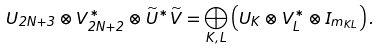Convert formula to latex. <formula><loc_0><loc_0><loc_500><loc_500>U _ { 2 N + 3 } \otimes V ^ { * } _ { 2 N + 2 } \otimes \widetilde { U } ^ { * } \widetilde { V } = \bigoplus _ { K , L } \left ( U _ { K } \otimes V ^ { * } _ { L } \otimes I _ { m _ { K L } } \right ) .</formula> 